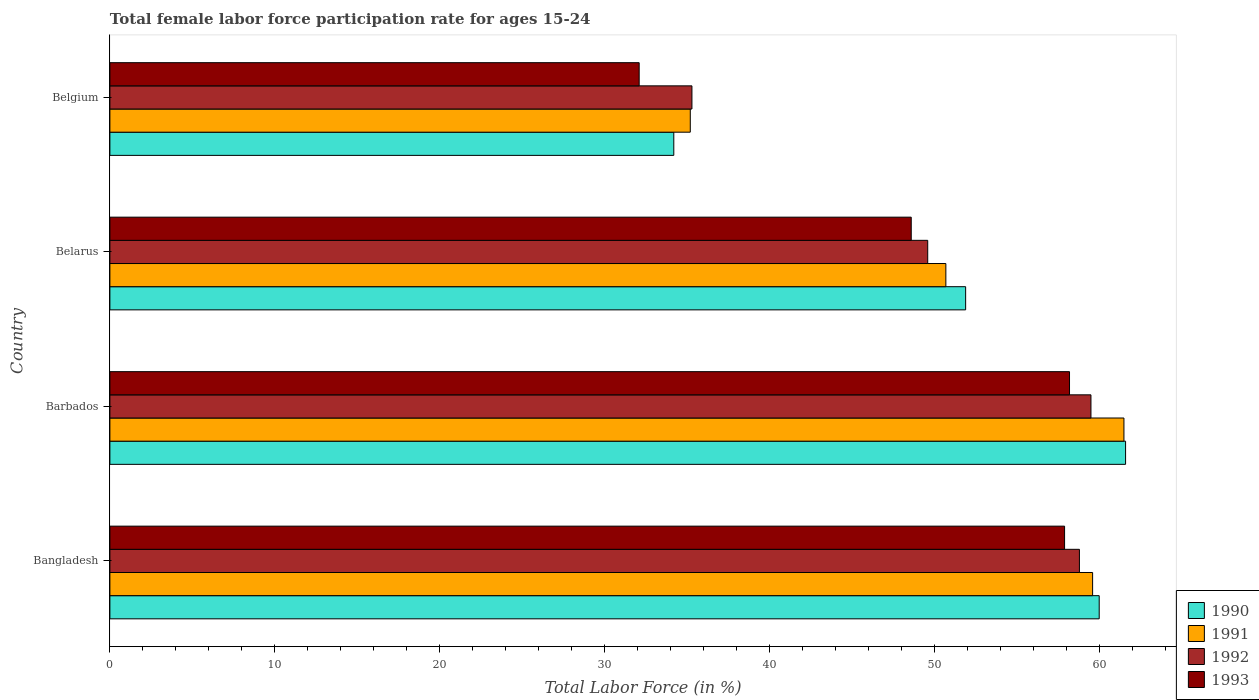Are the number of bars on each tick of the Y-axis equal?
Your response must be concise. Yes. How many bars are there on the 4th tick from the top?
Your answer should be very brief. 4. In how many cases, is the number of bars for a given country not equal to the number of legend labels?
Your answer should be very brief. 0. What is the female labor force participation rate in 1992 in Belgium?
Your answer should be compact. 35.3. Across all countries, what is the maximum female labor force participation rate in 1993?
Make the answer very short. 58.2. Across all countries, what is the minimum female labor force participation rate in 1993?
Offer a terse response. 32.1. In which country was the female labor force participation rate in 1991 maximum?
Make the answer very short. Barbados. In which country was the female labor force participation rate in 1993 minimum?
Your response must be concise. Belgium. What is the total female labor force participation rate in 1990 in the graph?
Keep it short and to the point. 207.7. What is the difference between the female labor force participation rate in 1991 in Bangladesh and that in Belgium?
Ensure brevity in your answer.  24.4. What is the difference between the female labor force participation rate in 1992 in Belarus and the female labor force participation rate in 1993 in Barbados?
Give a very brief answer. -8.6. What is the average female labor force participation rate in 1992 per country?
Offer a terse response. 50.8. What is the difference between the female labor force participation rate in 1990 and female labor force participation rate in 1993 in Bangladesh?
Provide a succinct answer. 2.1. What is the ratio of the female labor force participation rate in 1993 in Barbados to that in Belgium?
Ensure brevity in your answer.  1.81. Is the female labor force participation rate in 1993 in Bangladesh less than that in Belarus?
Provide a succinct answer. No. Is the difference between the female labor force participation rate in 1990 in Barbados and Belarus greater than the difference between the female labor force participation rate in 1993 in Barbados and Belarus?
Offer a terse response. Yes. What is the difference between the highest and the second highest female labor force participation rate in 1992?
Offer a terse response. 0.7. What is the difference between the highest and the lowest female labor force participation rate in 1990?
Keep it short and to the point. 27.4. Is the sum of the female labor force participation rate in 1993 in Barbados and Belarus greater than the maximum female labor force participation rate in 1992 across all countries?
Keep it short and to the point. Yes. What does the 2nd bar from the top in Belarus represents?
Keep it short and to the point. 1992. Is it the case that in every country, the sum of the female labor force participation rate in 1992 and female labor force participation rate in 1993 is greater than the female labor force participation rate in 1991?
Provide a short and direct response. Yes. How many bars are there?
Provide a short and direct response. 16. What is the difference between two consecutive major ticks on the X-axis?
Provide a short and direct response. 10. Does the graph contain grids?
Your answer should be compact. No. What is the title of the graph?
Your answer should be very brief. Total female labor force participation rate for ages 15-24. Does "1963" appear as one of the legend labels in the graph?
Your answer should be compact. No. What is the label or title of the X-axis?
Offer a terse response. Total Labor Force (in %). What is the Total Labor Force (in %) in 1990 in Bangladesh?
Provide a short and direct response. 60. What is the Total Labor Force (in %) of 1991 in Bangladesh?
Keep it short and to the point. 59.6. What is the Total Labor Force (in %) of 1992 in Bangladesh?
Ensure brevity in your answer.  58.8. What is the Total Labor Force (in %) of 1993 in Bangladesh?
Offer a terse response. 57.9. What is the Total Labor Force (in %) of 1990 in Barbados?
Provide a short and direct response. 61.6. What is the Total Labor Force (in %) of 1991 in Barbados?
Offer a terse response. 61.5. What is the Total Labor Force (in %) of 1992 in Barbados?
Your answer should be very brief. 59.5. What is the Total Labor Force (in %) of 1993 in Barbados?
Keep it short and to the point. 58.2. What is the Total Labor Force (in %) of 1990 in Belarus?
Your answer should be compact. 51.9. What is the Total Labor Force (in %) in 1991 in Belarus?
Your answer should be very brief. 50.7. What is the Total Labor Force (in %) of 1992 in Belarus?
Your response must be concise. 49.6. What is the Total Labor Force (in %) of 1993 in Belarus?
Your answer should be very brief. 48.6. What is the Total Labor Force (in %) in 1990 in Belgium?
Give a very brief answer. 34.2. What is the Total Labor Force (in %) of 1991 in Belgium?
Ensure brevity in your answer.  35.2. What is the Total Labor Force (in %) in 1992 in Belgium?
Make the answer very short. 35.3. What is the Total Labor Force (in %) in 1993 in Belgium?
Your answer should be very brief. 32.1. Across all countries, what is the maximum Total Labor Force (in %) of 1990?
Provide a succinct answer. 61.6. Across all countries, what is the maximum Total Labor Force (in %) of 1991?
Your answer should be very brief. 61.5. Across all countries, what is the maximum Total Labor Force (in %) in 1992?
Your response must be concise. 59.5. Across all countries, what is the maximum Total Labor Force (in %) in 1993?
Keep it short and to the point. 58.2. Across all countries, what is the minimum Total Labor Force (in %) of 1990?
Your response must be concise. 34.2. Across all countries, what is the minimum Total Labor Force (in %) in 1991?
Offer a very short reply. 35.2. Across all countries, what is the minimum Total Labor Force (in %) in 1992?
Your answer should be compact. 35.3. Across all countries, what is the minimum Total Labor Force (in %) in 1993?
Provide a succinct answer. 32.1. What is the total Total Labor Force (in %) of 1990 in the graph?
Offer a terse response. 207.7. What is the total Total Labor Force (in %) in 1991 in the graph?
Make the answer very short. 207. What is the total Total Labor Force (in %) in 1992 in the graph?
Keep it short and to the point. 203.2. What is the total Total Labor Force (in %) of 1993 in the graph?
Make the answer very short. 196.8. What is the difference between the Total Labor Force (in %) in 1991 in Bangladesh and that in Barbados?
Offer a very short reply. -1.9. What is the difference between the Total Labor Force (in %) of 1992 in Bangladesh and that in Barbados?
Your answer should be very brief. -0.7. What is the difference between the Total Labor Force (in %) in 1993 in Bangladesh and that in Barbados?
Keep it short and to the point. -0.3. What is the difference between the Total Labor Force (in %) in 1990 in Bangladesh and that in Belarus?
Your response must be concise. 8.1. What is the difference between the Total Labor Force (in %) of 1991 in Bangladesh and that in Belarus?
Give a very brief answer. 8.9. What is the difference between the Total Labor Force (in %) in 1990 in Bangladesh and that in Belgium?
Make the answer very short. 25.8. What is the difference between the Total Labor Force (in %) in 1991 in Bangladesh and that in Belgium?
Give a very brief answer. 24.4. What is the difference between the Total Labor Force (in %) of 1993 in Bangladesh and that in Belgium?
Give a very brief answer. 25.8. What is the difference between the Total Labor Force (in %) in 1990 in Barbados and that in Belarus?
Make the answer very short. 9.7. What is the difference between the Total Labor Force (in %) of 1993 in Barbados and that in Belarus?
Offer a very short reply. 9.6. What is the difference between the Total Labor Force (in %) in 1990 in Barbados and that in Belgium?
Offer a terse response. 27.4. What is the difference between the Total Labor Force (in %) of 1991 in Barbados and that in Belgium?
Your answer should be compact. 26.3. What is the difference between the Total Labor Force (in %) of 1992 in Barbados and that in Belgium?
Your answer should be compact. 24.2. What is the difference between the Total Labor Force (in %) of 1993 in Barbados and that in Belgium?
Ensure brevity in your answer.  26.1. What is the difference between the Total Labor Force (in %) of 1990 in Belarus and that in Belgium?
Make the answer very short. 17.7. What is the difference between the Total Labor Force (in %) of 1991 in Belarus and that in Belgium?
Offer a very short reply. 15.5. What is the difference between the Total Labor Force (in %) of 1992 in Belarus and that in Belgium?
Your answer should be very brief. 14.3. What is the difference between the Total Labor Force (in %) in 1990 in Bangladesh and the Total Labor Force (in %) in 1991 in Barbados?
Make the answer very short. -1.5. What is the difference between the Total Labor Force (in %) of 1990 in Bangladesh and the Total Labor Force (in %) of 1992 in Barbados?
Ensure brevity in your answer.  0.5. What is the difference between the Total Labor Force (in %) in 1991 in Bangladesh and the Total Labor Force (in %) in 1993 in Barbados?
Your answer should be very brief. 1.4. What is the difference between the Total Labor Force (in %) in 1992 in Bangladesh and the Total Labor Force (in %) in 1993 in Barbados?
Your response must be concise. 0.6. What is the difference between the Total Labor Force (in %) in 1990 in Bangladesh and the Total Labor Force (in %) in 1992 in Belarus?
Offer a terse response. 10.4. What is the difference between the Total Labor Force (in %) of 1990 in Bangladesh and the Total Labor Force (in %) of 1991 in Belgium?
Give a very brief answer. 24.8. What is the difference between the Total Labor Force (in %) in 1990 in Bangladesh and the Total Labor Force (in %) in 1992 in Belgium?
Keep it short and to the point. 24.7. What is the difference between the Total Labor Force (in %) of 1990 in Bangladesh and the Total Labor Force (in %) of 1993 in Belgium?
Offer a very short reply. 27.9. What is the difference between the Total Labor Force (in %) in 1991 in Bangladesh and the Total Labor Force (in %) in 1992 in Belgium?
Ensure brevity in your answer.  24.3. What is the difference between the Total Labor Force (in %) of 1991 in Bangladesh and the Total Labor Force (in %) of 1993 in Belgium?
Make the answer very short. 27.5. What is the difference between the Total Labor Force (in %) in 1992 in Bangladesh and the Total Labor Force (in %) in 1993 in Belgium?
Provide a short and direct response. 26.7. What is the difference between the Total Labor Force (in %) in 1990 in Barbados and the Total Labor Force (in %) in 1991 in Belarus?
Provide a short and direct response. 10.9. What is the difference between the Total Labor Force (in %) of 1992 in Barbados and the Total Labor Force (in %) of 1993 in Belarus?
Offer a terse response. 10.9. What is the difference between the Total Labor Force (in %) in 1990 in Barbados and the Total Labor Force (in %) in 1991 in Belgium?
Your answer should be very brief. 26.4. What is the difference between the Total Labor Force (in %) in 1990 in Barbados and the Total Labor Force (in %) in 1992 in Belgium?
Provide a succinct answer. 26.3. What is the difference between the Total Labor Force (in %) of 1990 in Barbados and the Total Labor Force (in %) of 1993 in Belgium?
Provide a short and direct response. 29.5. What is the difference between the Total Labor Force (in %) of 1991 in Barbados and the Total Labor Force (in %) of 1992 in Belgium?
Provide a short and direct response. 26.2. What is the difference between the Total Labor Force (in %) in 1991 in Barbados and the Total Labor Force (in %) in 1993 in Belgium?
Your answer should be very brief. 29.4. What is the difference between the Total Labor Force (in %) of 1992 in Barbados and the Total Labor Force (in %) of 1993 in Belgium?
Your answer should be very brief. 27.4. What is the difference between the Total Labor Force (in %) in 1990 in Belarus and the Total Labor Force (in %) in 1991 in Belgium?
Offer a very short reply. 16.7. What is the difference between the Total Labor Force (in %) in 1990 in Belarus and the Total Labor Force (in %) in 1992 in Belgium?
Keep it short and to the point. 16.6. What is the difference between the Total Labor Force (in %) of 1990 in Belarus and the Total Labor Force (in %) of 1993 in Belgium?
Your answer should be compact. 19.8. What is the difference between the Total Labor Force (in %) of 1991 in Belarus and the Total Labor Force (in %) of 1992 in Belgium?
Give a very brief answer. 15.4. What is the average Total Labor Force (in %) of 1990 per country?
Your answer should be compact. 51.92. What is the average Total Labor Force (in %) in 1991 per country?
Offer a terse response. 51.75. What is the average Total Labor Force (in %) of 1992 per country?
Give a very brief answer. 50.8. What is the average Total Labor Force (in %) in 1993 per country?
Provide a succinct answer. 49.2. What is the difference between the Total Labor Force (in %) in 1990 and Total Labor Force (in %) in 1992 in Bangladesh?
Your answer should be compact. 1.2. What is the difference between the Total Labor Force (in %) of 1991 and Total Labor Force (in %) of 1993 in Bangladesh?
Your response must be concise. 1.7. What is the difference between the Total Labor Force (in %) in 1992 and Total Labor Force (in %) in 1993 in Bangladesh?
Provide a short and direct response. 0.9. What is the difference between the Total Labor Force (in %) in 1990 and Total Labor Force (in %) in 1993 in Barbados?
Ensure brevity in your answer.  3.4. What is the difference between the Total Labor Force (in %) in 1991 and Total Labor Force (in %) in 1992 in Barbados?
Ensure brevity in your answer.  2. What is the difference between the Total Labor Force (in %) in 1991 and Total Labor Force (in %) in 1993 in Barbados?
Offer a terse response. 3.3. What is the difference between the Total Labor Force (in %) of 1990 and Total Labor Force (in %) of 1991 in Belarus?
Offer a terse response. 1.2. What is the difference between the Total Labor Force (in %) in 1990 and Total Labor Force (in %) in 1993 in Belarus?
Give a very brief answer. 3.3. What is the difference between the Total Labor Force (in %) in 1992 and Total Labor Force (in %) in 1993 in Belarus?
Offer a very short reply. 1. What is the difference between the Total Labor Force (in %) in 1990 and Total Labor Force (in %) in 1991 in Belgium?
Your answer should be compact. -1. What is the difference between the Total Labor Force (in %) in 1990 and Total Labor Force (in %) in 1992 in Belgium?
Your answer should be very brief. -1.1. What is the difference between the Total Labor Force (in %) of 1990 and Total Labor Force (in %) of 1993 in Belgium?
Keep it short and to the point. 2.1. What is the difference between the Total Labor Force (in %) in 1991 and Total Labor Force (in %) in 1993 in Belgium?
Your answer should be very brief. 3.1. What is the ratio of the Total Labor Force (in %) in 1990 in Bangladesh to that in Barbados?
Your answer should be compact. 0.97. What is the ratio of the Total Labor Force (in %) of 1991 in Bangladesh to that in Barbados?
Make the answer very short. 0.97. What is the ratio of the Total Labor Force (in %) in 1990 in Bangladesh to that in Belarus?
Your answer should be compact. 1.16. What is the ratio of the Total Labor Force (in %) of 1991 in Bangladesh to that in Belarus?
Provide a succinct answer. 1.18. What is the ratio of the Total Labor Force (in %) of 1992 in Bangladesh to that in Belarus?
Keep it short and to the point. 1.19. What is the ratio of the Total Labor Force (in %) in 1993 in Bangladesh to that in Belarus?
Your answer should be compact. 1.19. What is the ratio of the Total Labor Force (in %) in 1990 in Bangladesh to that in Belgium?
Ensure brevity in your answer.  1.75. What is the ratio of the Total Labor Force (in %) of 1991 in Bangladesh to that in Belgium?
Make the answer very short. 1.69. What is the ratio of the Total Labor Force (in %) of 1992 in Bangladesh to that in Belgium?
Offer a very short reply. 1.67. What is the ratio of the Total Labor Force (in %) of 1993 in Bangladesh to that in Belgium?
Keep it short and to the point. 1.8. What is the ratio of the Total Labor Force (in %) in 1990 in Barbados to that in Belarus?
Offer a terse response. 1.19. What is the ratio of the Total Labor Force (in %) in 1991 in Barbados to that in Belarus?
Keep it short and to the point. 1.21. What is the ratio of the Total Labor Force (in %) of 1992 in Barbados to that in Belarus?
Your answer should be very brief. 1.2. What is the ratio of the Total Labor Force (in %) in 1993 in Barbados to that in Belarus?
Your response must be concise. 1.2. What is the ratio of the Total Labor Force (in %) in 1990 in Barbados to that in Belgium?
Offer a very short reply. 1.8. What is the ratio of the Total Labor Force (in %) in 1991 in Barbados to that in Belgium?
Your answer should be compact. 1.75. What is the ratio of the Total Labor Force (in %) in 1992 in Barbados to that in Belgium?
Give a very brief answer. 1.69. What is the ratio of the Total Labor Force (in %) of 1993 in Barbados to that in Belgium?
Offer a very short reply. 1.81. What is the ratio of the Total Labor Force (in %) of 1990 in Belarus to that in Belgium?
Give a very brief answer. 1.52. What is the ratio of the Total Labor Force (in %) of 1991 in Belarus to that in Belgium?
Keep it short and to the point. 1.44. What is the ratio of the Total Labor Force (in %) of 1992 in Belarus to that in Belgium?
Offer a terse response. 1.41. What is the ratio of the Total Labor Force (in %) of 1993 in Belarus to that in Belgium?
Make the answer very short. 1.51. What is the difference between the highest and the second highest Total Labor Force (in %) of 1990?
Make the answer very short. 1.6. What is the difference between the highest and the second highest Total Labor Force (in %) of 1992?
Make the answer very short. 0.7. What is the difference between the highest and the lowest Total Labor Force (in %) in 1990?
Keep it short and to the point. 27.4. What is the difference between the highest and the lowest Total Labor Force (in %) of 1991?
Your answer should be compact. 26.3. What is the difference between the highest and the lowest Total Labor Force (in %) in 1992?
Ensure brevity in your answer.  24.2. What is the difference between the highest and the lowest Total Labor Force (in %) of 1993?
Make the answer very short. 26.1. 